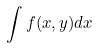<formula> <loc_0><loc_0><loc_500><loc_500>\int f ( x , y ) d x</formula> 